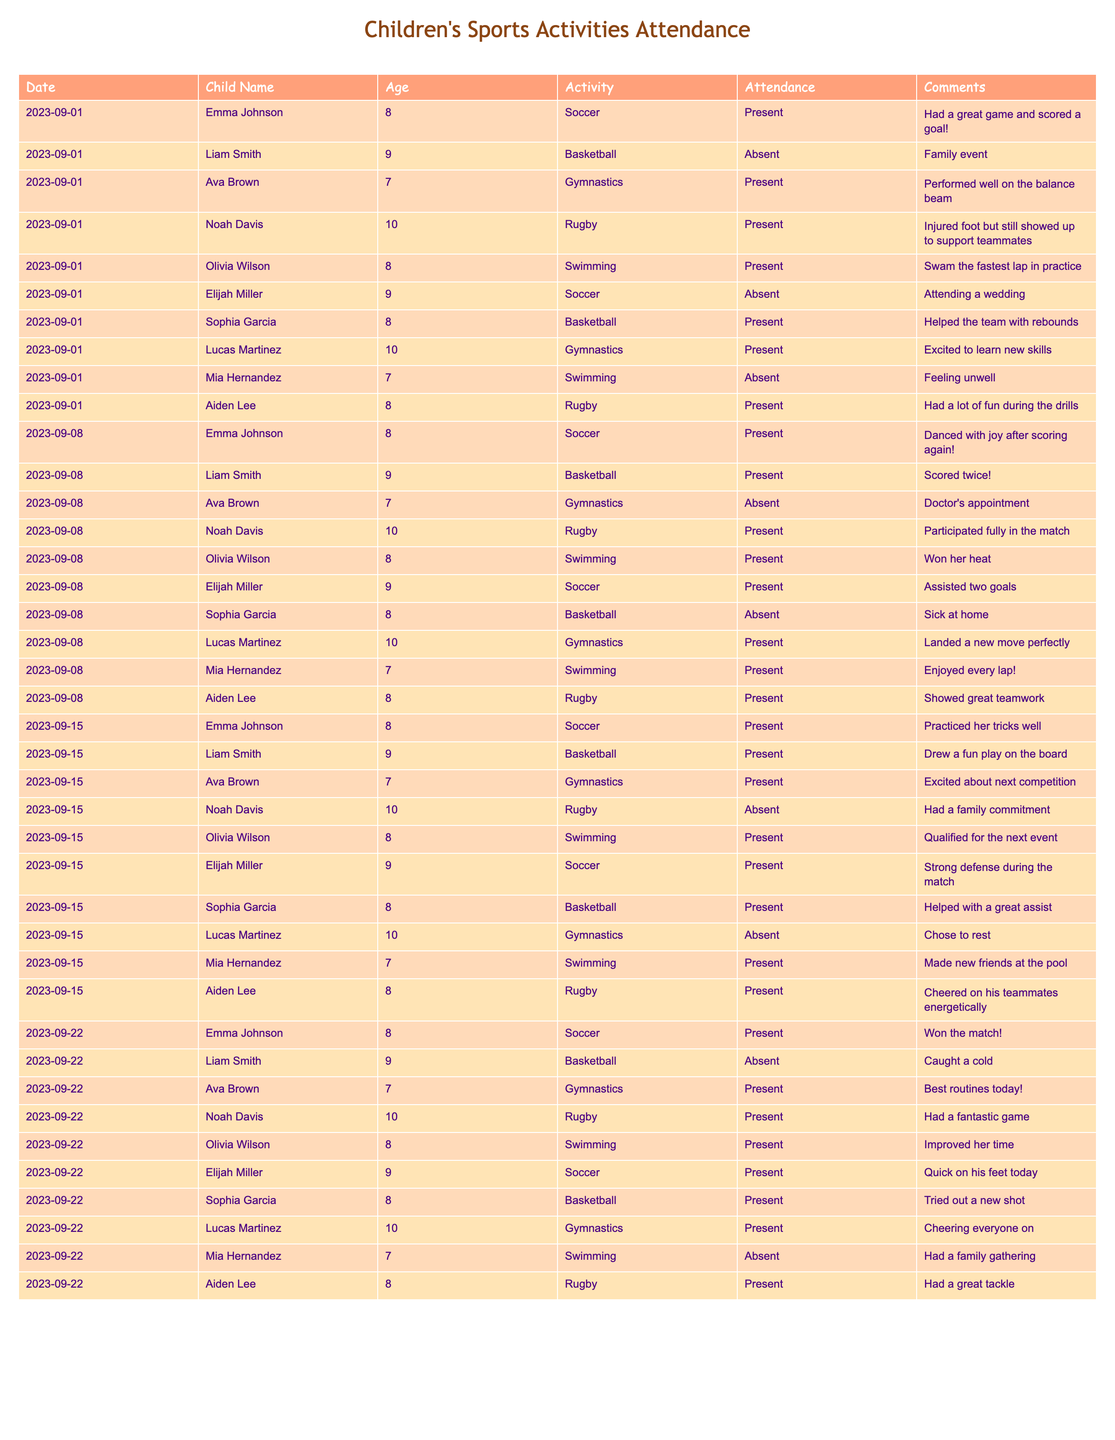What percentage of the children were present for all activities on September 1st? There were 8 children listed for September 1st, and 5 of them were present. To find the percentage, we calculate (5/8) * 100 = 62.5%.
Answer: 62.5% How many times did Emma Johnson attend activities throughout the month? Emma Johnson was present in 4 out of the 4 recorded sessions in September, as she was listed each time and marked as present.
Answer: 4 Did any child miss more than one activity over the span of the month? By reviewing the attendance records, it can be seen that Liam Smith missed 3 sessions (September 1st, 22nd, and 15th) while other children missed either one or two. Thus, he is the only one who missed more than one activity.
Answer: Yes Which activity had the highest attendance among the children on September 15th? On September 15th, there were 6 children present for the activities: Soccer (4), Swimming (3), Basketball (3), and Gymnastics (2). Soccer had the highest attendance with 4 children.
Answer: Soccer How many total absences were recorded across all children during September? By counting the absences in the provided data, we find 5 on September 1st, 2 on September 8th, 2 on September 15th, and 1 on September 22nd. Adding these gives us a total of 10 absences.
Answer: 10 Was there a child named Aiden Lee who participated in every activity for the month? Aiden Lee attended every session: he was present on September 1st, 8th, 15th, and 22nd with attendance noted each time. Thus, he did not miss any activities.
Answer: Yes What was the most common comment made about the swimming activities? Reviewing the comments for swimming on each date, the overall theme was positive about performance like winning heats or enjoying laps, but ‘enjoyed every lap’ was mentioned in Mia's comment which kids often relate positively to.
Answer: Enjoyed laps How many children aged 7 were present on September 22nd? There were 4 children aged 7: Ava Brown (present), Mia Hernandez (absent) which leads to only Ava counted as present for swimming that day.
Answer: 1 Who had the most positive feedback according to the comments? By reviewing the comments, Emma Johnson consistently received the most positive mentions including scoring a goal, winning matches, and having joyful reactions.
Answer: Emma Johnson What age group showed the highest attendance across all activities for the month? By analyzing attendance, we find that 8-year-olds were consistently present at each session, thus having the highest attendance over the month better than other age groups.
Answer: 8 Did any of the children participate in more than one sport throughout the month? Reviewing the records, it can be observed that none of the children engaged in more than one sport individually as all participated in their specific listed sport activities.
Answer: No 